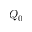Convert formula to latex. <formula><loc_0><loc_0><loc_500><loc_500>Q _ { 0 }</formula> 